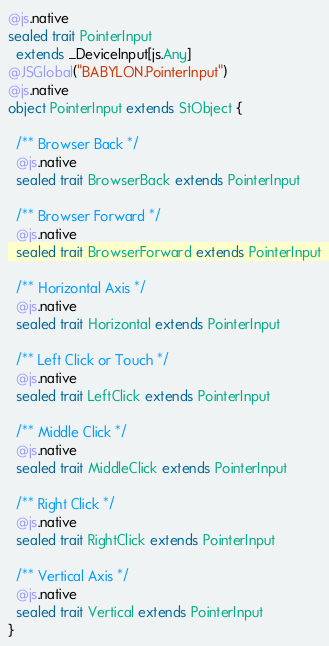<code> <loc_0><loc_0><loc_500><loc_500><_Scala_>
@js.native
sealed trait PointerInput
  extends _DeviceInput[js.Any]
@JSGlobal("BABYLON.PointerInput")
@js.native
object PointerInput extends StObject {
  
  /** Browser Back */
  @js.native
  sealed trait BrowserBack extends PointerInput
  
  /** Browser Forward */
  @js.native
  sealed trait BrowserForward extends PointerInput
  
  /** Horizontal Axis */
  @js.native
  sealed trait Horizontal extends PointerInput
  
  /** Left Click or Touch */
  @js.native
  sealed trait LeftClick extends PointerInput
  
  /** Middle Click */
  @js.native
  sealed trait MiddleClick extends PointerInput
  
  /** Right Click */
  @js.native
  sealed trait RightClick extends PointerInput
  
  /** Vertical Axis */
  @js.native
  sealed trait Vertical extends PointerInput
}
</code> 